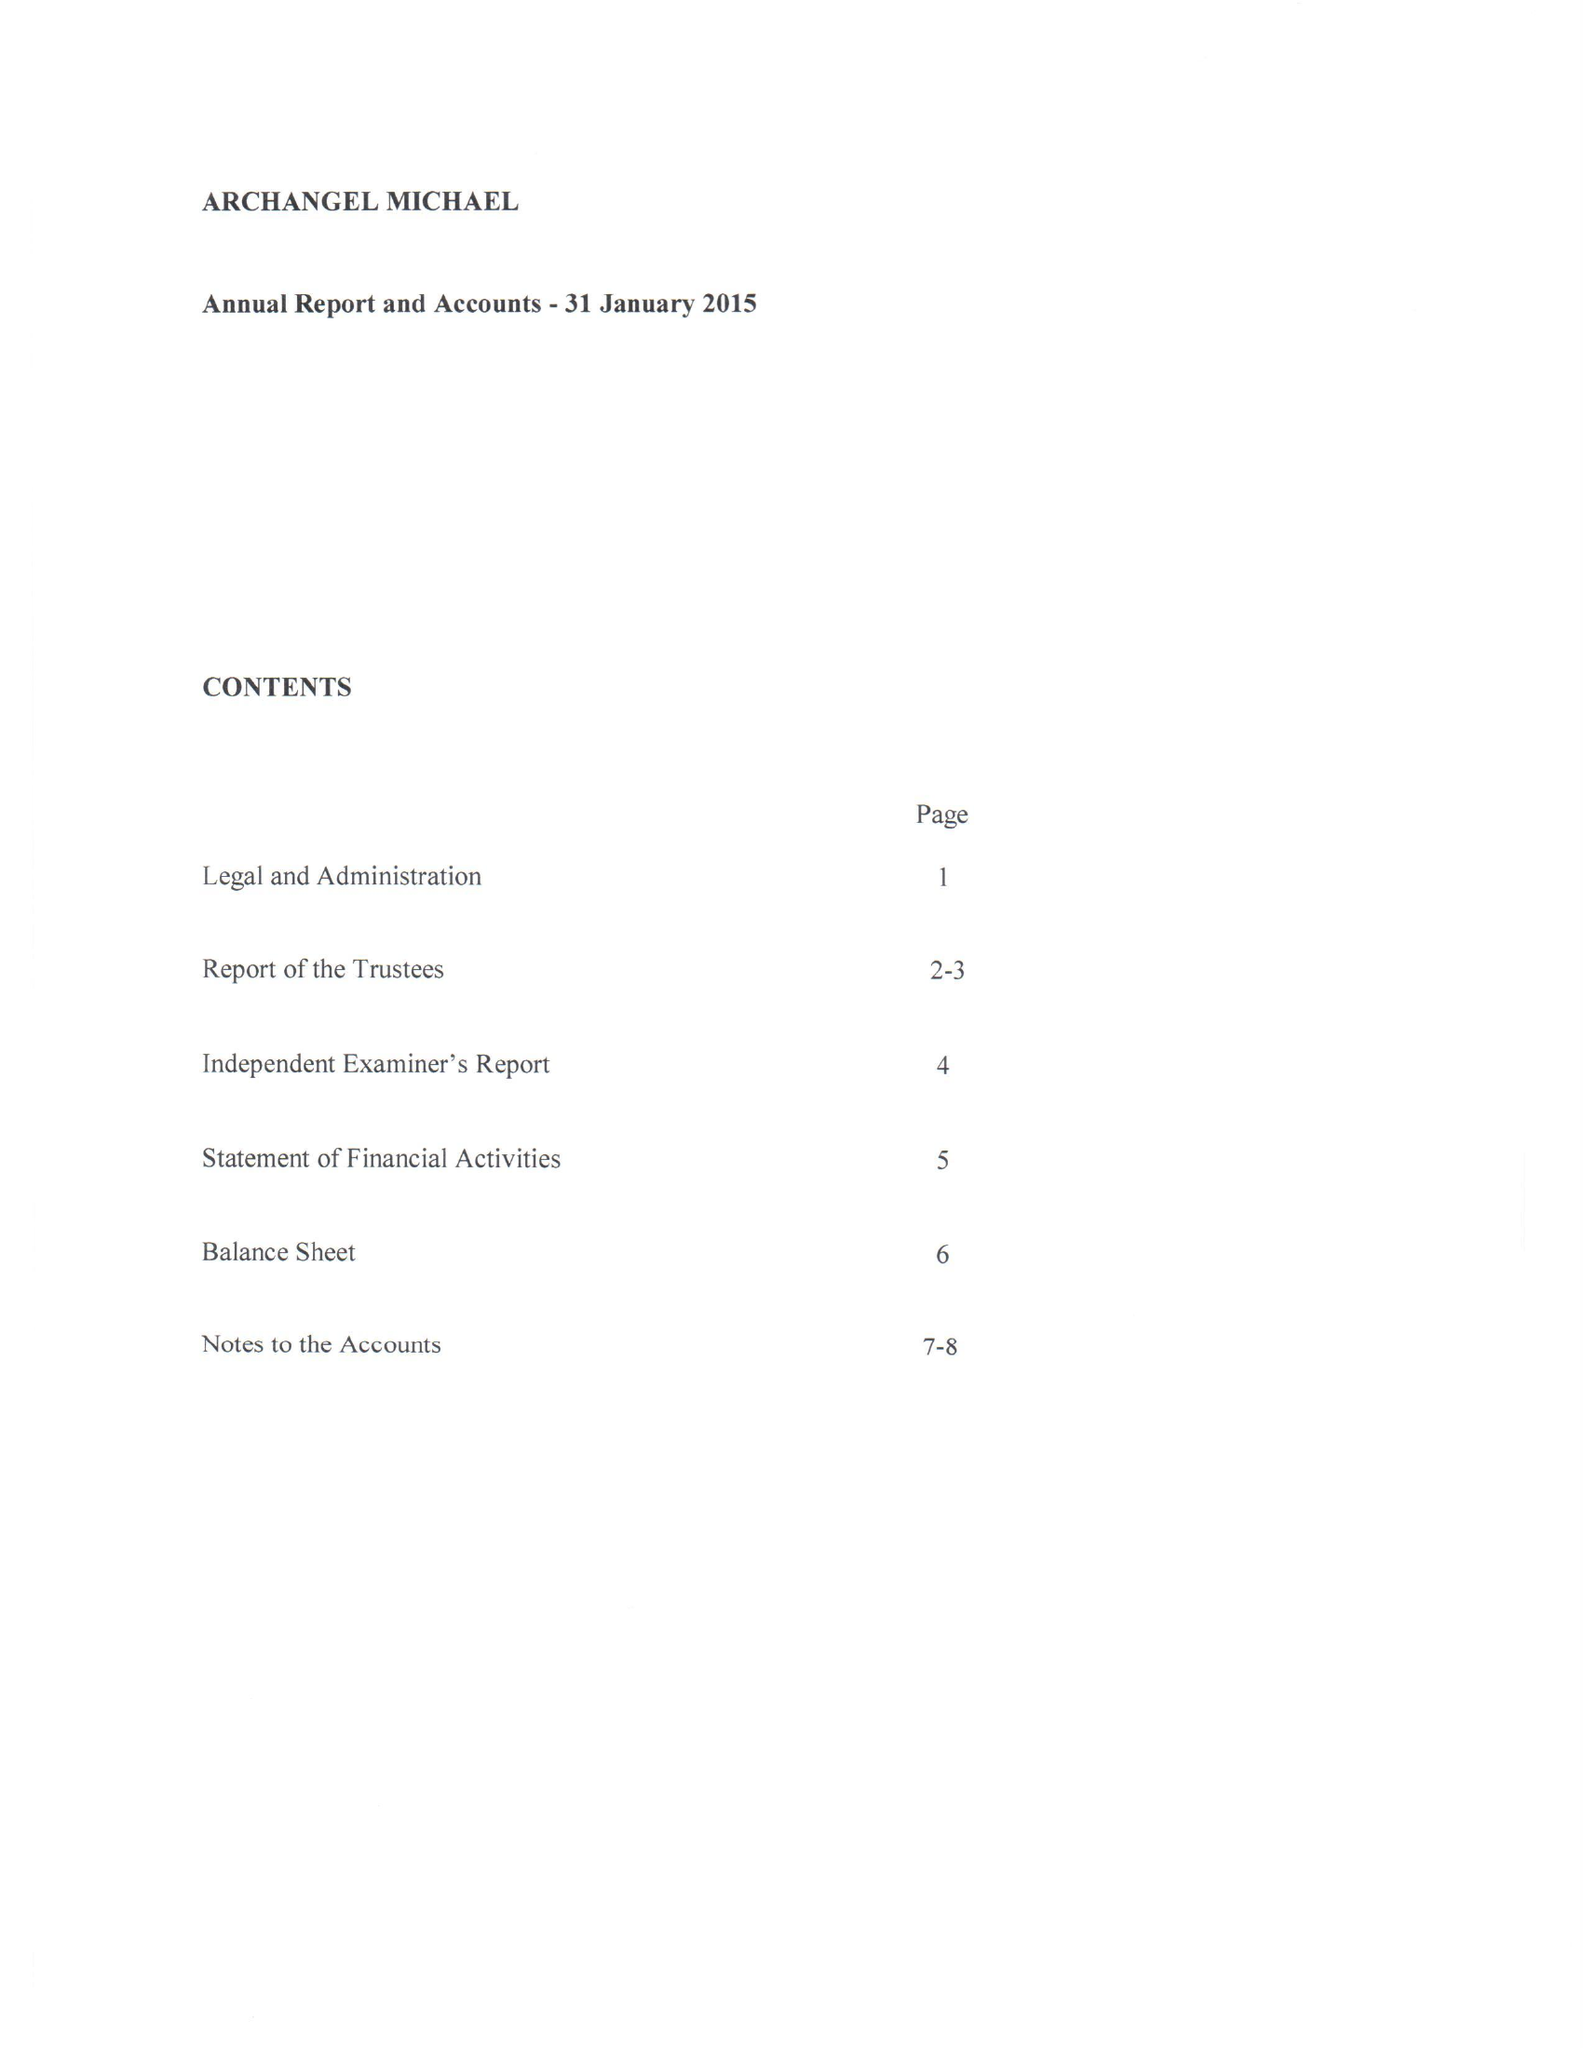What is the value for the charity_number?
Answer the question using a single word or phrase. 1135277 